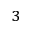<formula> <loc_0><loc_0><loc_500><loc_500>^ { 3 }</formula> 